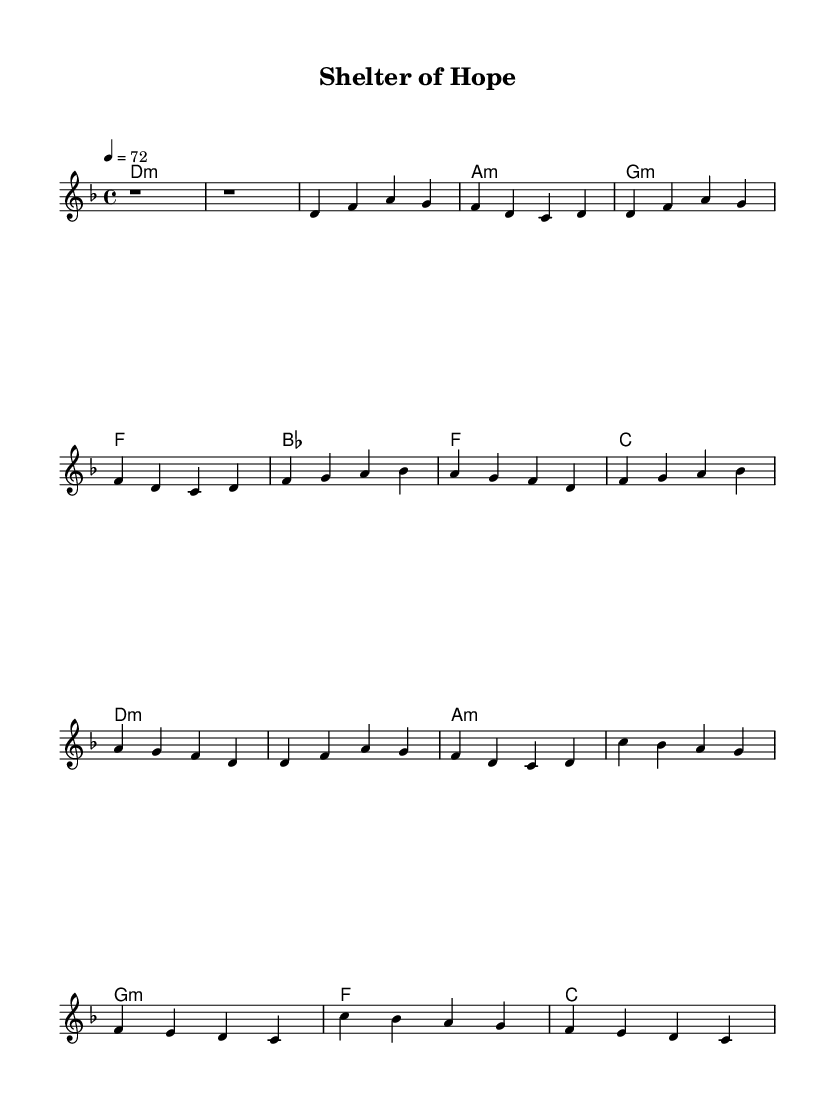What is the key signature of this music? The key signature appears to be D minor, which corresponds to one flat (B flat) in the key signature box.
Answer: D minor What is the time signature of this music? The time signature written at the beginning of the sheet music is 4/4, indicating four beats per measure.
Answer: 4/4 What is the tempo marking specified in the sheet music? The tempo marking is indicated as 4 = 72, which means there are 72 beats per minute, setting the pace of the piece.
Answer: 72 In how many measures does the intro section consist? The intro section consists of two measures, as indicated by the two 'r1' rest symbols present.
Answer: 2 What chord is used in measure 3 of the verse? The chord in measure 3 of the verse is labeled as G minor, which is the third chord in the progression for that section.
Answer: G minor How many times is the melody repeated in the chorus? The melody in the chorus section is repeated twice, as shown by the similar musical notation appearing consecutively.
Answer: 2 What social theme does the song's title suggest? The song’s title "Shelter of Hope" implies themes of community support and assistance to those in need.
Answer: Community support 